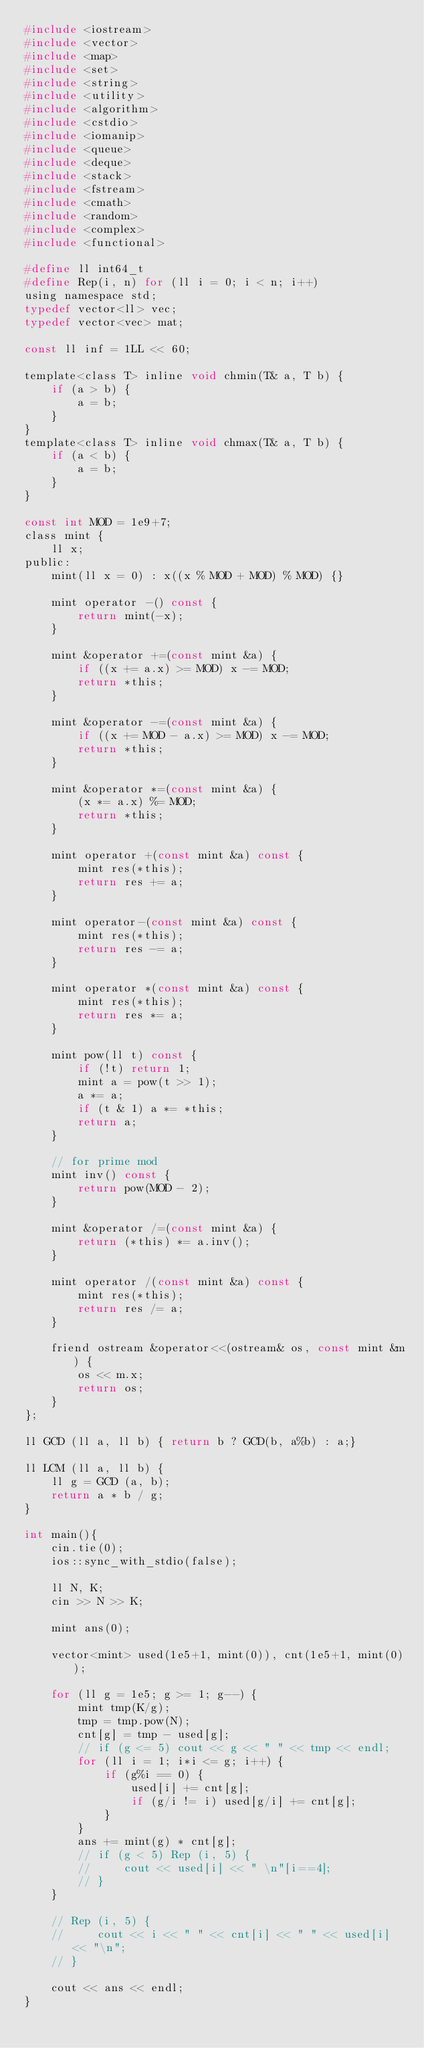Convert code to text. <code><loc_0><loc_0><loc_500><loc_500><_C_>#include <iostream>
#include <vector>
#include <map>
#include <set>
#include <string>
#include <utility>
#include <algorithm>
#include <cstdio>
#include <iomanip>
#include <queue>
#include <deque>
#include <stack>
#include <fstream>
#include <cmath>
#include <random>
#include <complex>
#include <functional>

#define ll int64_t
#define Rep(i, n) for (ll i = 0; i < n; i++)
using namespace std;
typedef vector<ll> vec;
typedef vector<vec> mat;

const ll inf = 1LL << 60;

template<class T> inline void chmin(T& a, T b) {
    if (a > b) {
        a = b;
    }
}
template<class T> inline void chmax(T& a, T b) {
    if (a < b) {
        a = b;
    }
}

const int MOD = 1e9+7;
class mint {
    ll x;
public:
    mint(ll x = 0) : x((x % MOD + MOD) % MOD) {}
    
    mint operator -() const {
        return mint(-x);
    }
    
    mint &operator +=(const mint &a) {
        if ((x += a.x) >= MOD) x -= MOD;
        return *this;
    }

    mint &operator -=(const mint &a) {
        if ((x += MOD - a.x) >= MOD) x -= MOD;
        return *this;
    }

    mint &operator *=(const mint &a) {
        (x *= a.x) %= MOD;
        return *this;
    }

    mint operator +(const mint &a) const {
        mint res(*this);
        return res += a;
    }

    mint operator-(const mint &a) const {
        mint res(*this);
        return res -= a;
    }

    mint operator *(const mint &a) const {
        mint res(*this);
        return res *= a;
    }

    mint pow(ll t) const {
        if (!t) return 1;
        mint a = pow(t >> 1);
        a *= a;
        if (t & 1) a *= *this;
        return a;
    }

    // for prime mod
    mint inv() const {
        return pow(MOD - 2);
    }

    mint &operator /=(const mint &a) {
        return (*this) *= a.inv();
    }

    mint operator /(const mint &a) const {
        mint res(*this);
        return res /= a;
    }

    friend ostream &operator<<(ostream& os, const mint &m) {
        os << m.x;
        return os;
    }
};

ll GCD (ll a, ll b) { return b ? GCD(b, a%b) : a;}

ll LCM (ll a, ll b) {
    ll g = GCD (a, b);
    return a * b / g;
}

int main(){
    cin.tie(0);
    ios::sync_with_stdio(false);

    ll N, K;
    cin >> N >> K;

    mint ans(0);

    vector<mint> used(1e5+1, mint(0)), cnt(1e5+1, mint(0));

    for (ll g = 1e5; g >= 1; g--) {
        mint tmp(K/g);
        tmp = tmp.pow(N);
        cnt[g] = tmp - used[g];
        // if (g <= 5) cout << g << " " << tmp << endl;
        for (ll i = 1; i*i <= g; i++) {
            if (g%i == 0) {
                used[i] += cnt[g];
                if (g/i != i) used[g/i] += cnt[g];
            }
        }
        ans += mint(g) * cnt[g];
        // if (g < 5) Rep (i, 5) {
        //     cout << used[i] << " \n"[i==4];
        // }
    }

    // Rep (i, 5) {
    //     cout << i << " " << cnt[i] << " " << used[i] << "\n";
    // }

    cout << ans << endl;
}</code> 